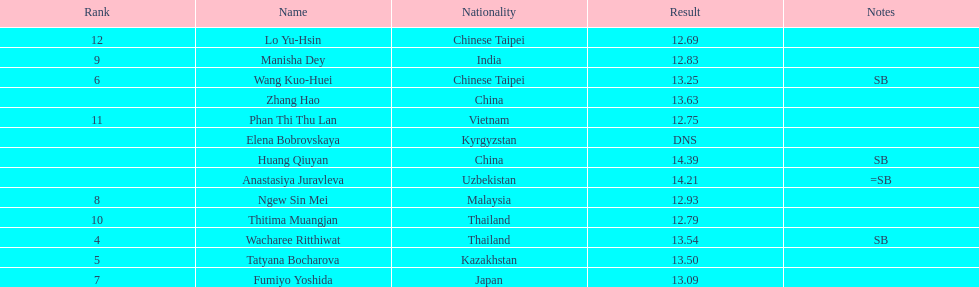How long was manisha dey's jump? 12.83. 